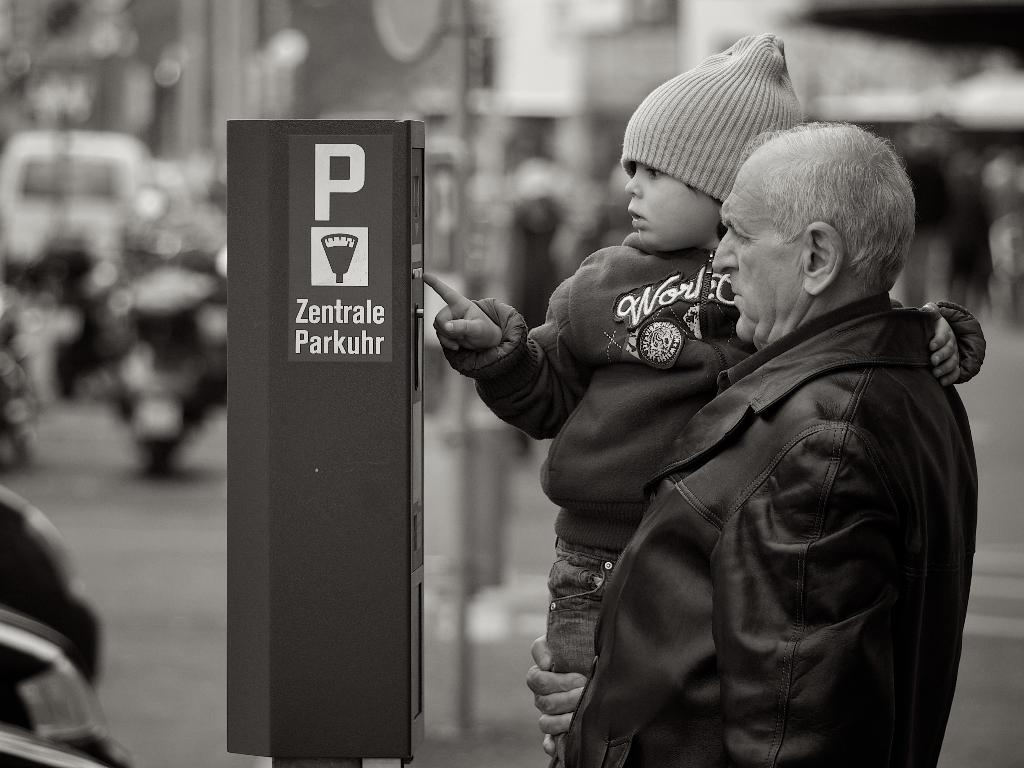Provide a one-sentence caption for the provided image. a boy looking at something next to the letter P on a sign. 